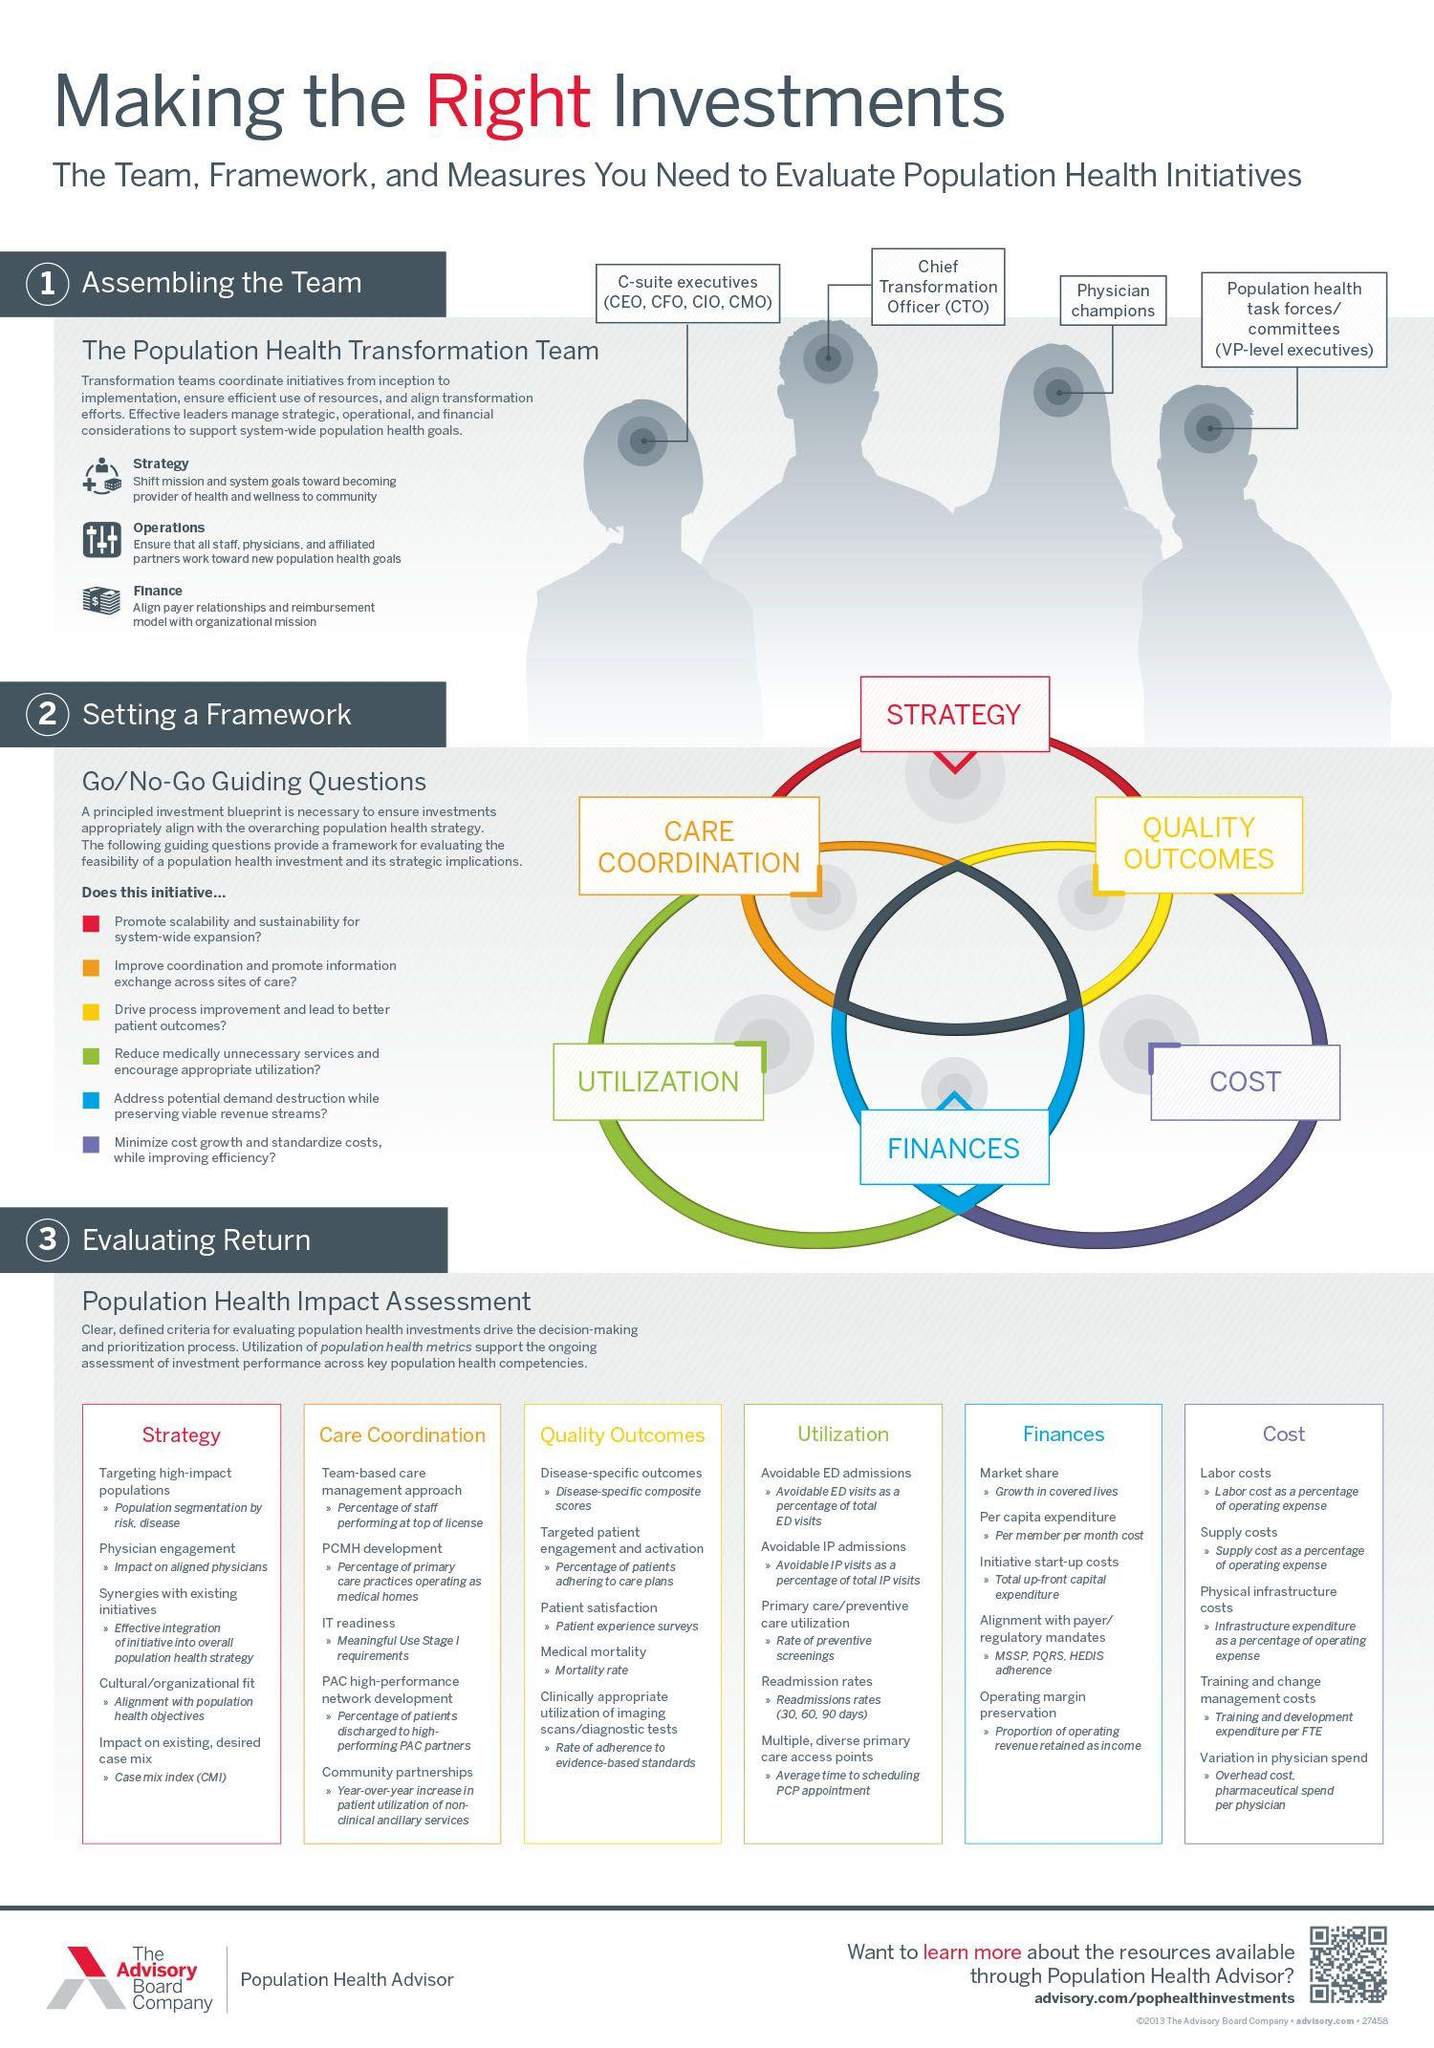List a handful of essential elements in this visual. The process of evaluating the return on investment for a project involves six steps. Setting a framework requires 6 steps. 